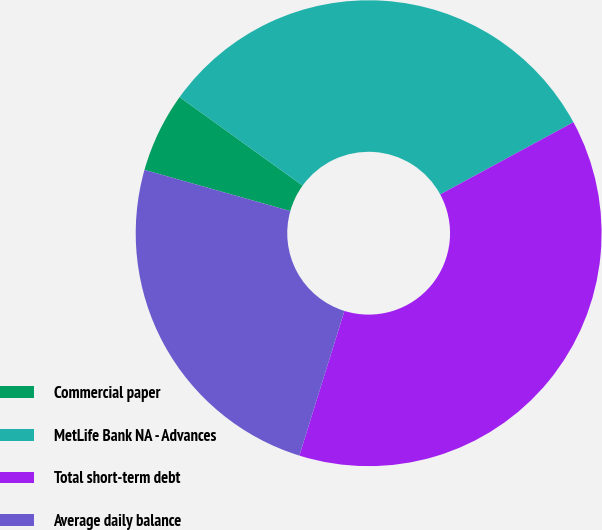Convert chart. <chart><loc_0><loc_0><loc_500><loc_500><pie_chart><fcel>Commercial paper<fcel>MetLife Bank NA - Advances<fcel>Total short-term debt<fcel>Average daily balance<nl><fcel>5.55%<fcel>32.16%<fcel>37.71%<fcel>24.57%<nl></chart> 